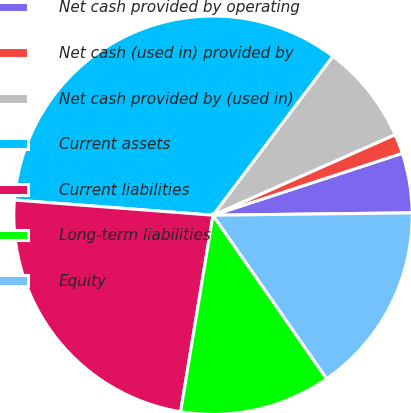<chart> <loc_0><loc_0><loc_500><loc_500><pie_chart><fcel>Net cash provided by operating<fcel>Net cash (used in) provided by<fcel>Net cash provided by (used in)<fcel>Current assets<fcel>Current liabilities<fcel>Long-term liabilities<fcel>Equity<nl><fcel>4.84%<fcel>1.6%<fcel>8.09%<fcel>34.07%<fcel>23.62%<fcel>12.27%<fcel>15.52%<nl></chart> 